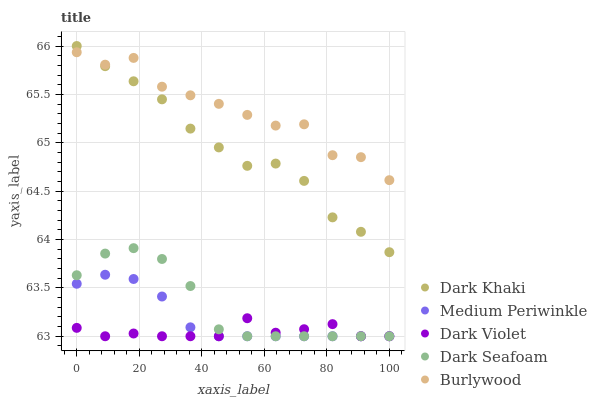Does Dark Violet have the minimum area under the curve?
Answer yes or no. Yes. Does Burlywood have the maximum area under the curve?
Answer yes or no. Yes. Does Dark Seafoam have the minimum area under the curve?
Answer yes or no. No. Does Dark Seafoam have the maximum area under the curve?
Answer yes or no. No. Is Medium Periwinkle the smoothest?
Answer yes or no. Yes. Is Burlywood the roughest?
Answer yes or no. Yes. Is Dark Seafoam the smoothest?
Answer yes or no. No. Is Dark Seafoam the roughest?
Answer yes or no. No. Does Dark Seafoam have the lowest value?
Answer yes or no. Yes. Does Burlywood have the lowest value?
Answer yes or no. No. Does Dark Khaki have the highest value?
Answer yes or no. Yes. Does Burlywood have the highest value?
Answer yes or no. No. Is Medium Periwinkle less than Dark Khaki?
Answer yes or no. Yes. Is Dark Khaki greater than Dark Violet?
Answer yes or no. Yes. Does Medium Periwinkle intersect Dark Violet?
Answer yes or no. Yes. Is Medium Periwinkle less than Dark Violet?
Answer yes or no. No. Is Medium Periwinkle greater than Dark Violet?
Answer yes or no. No. Does Medium Periwinkle intersect Dark Khaki?
Answer yes or no. No. 